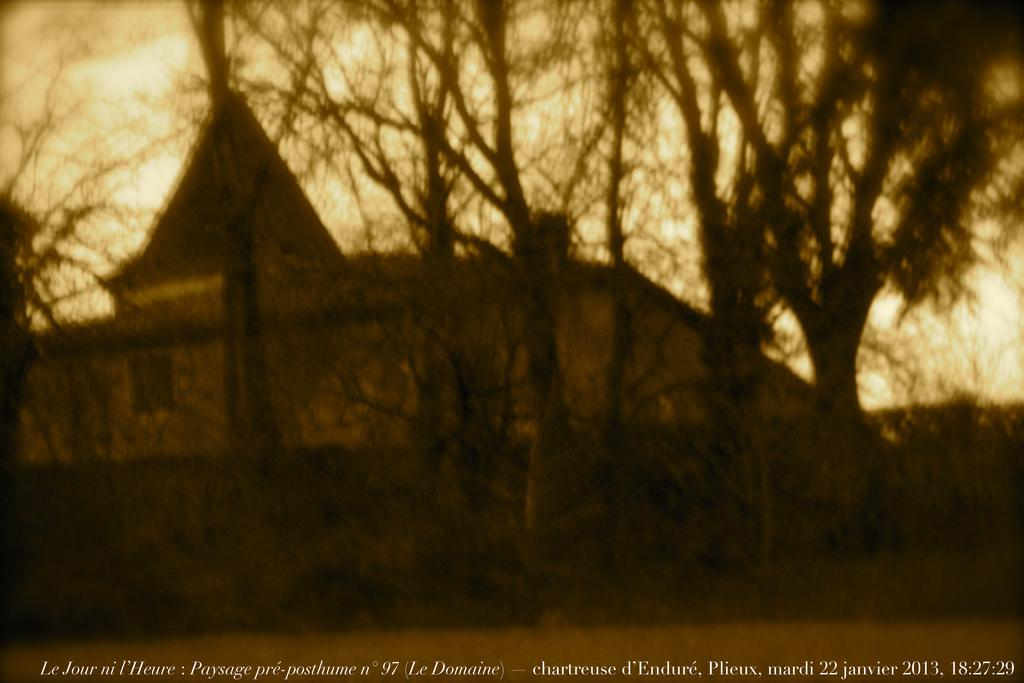What is the overall quality of the image? The image is slightly blurred. What type of structure can be seen in the image? There is a house in the image. What other natural elements are present in the image? There are trees in the image. What can be seen in the background of the image? The sky is visible in the background of the image. What type of plant is growing on the silver fruit in the image? There is no plant or silver fruit present in the image. 